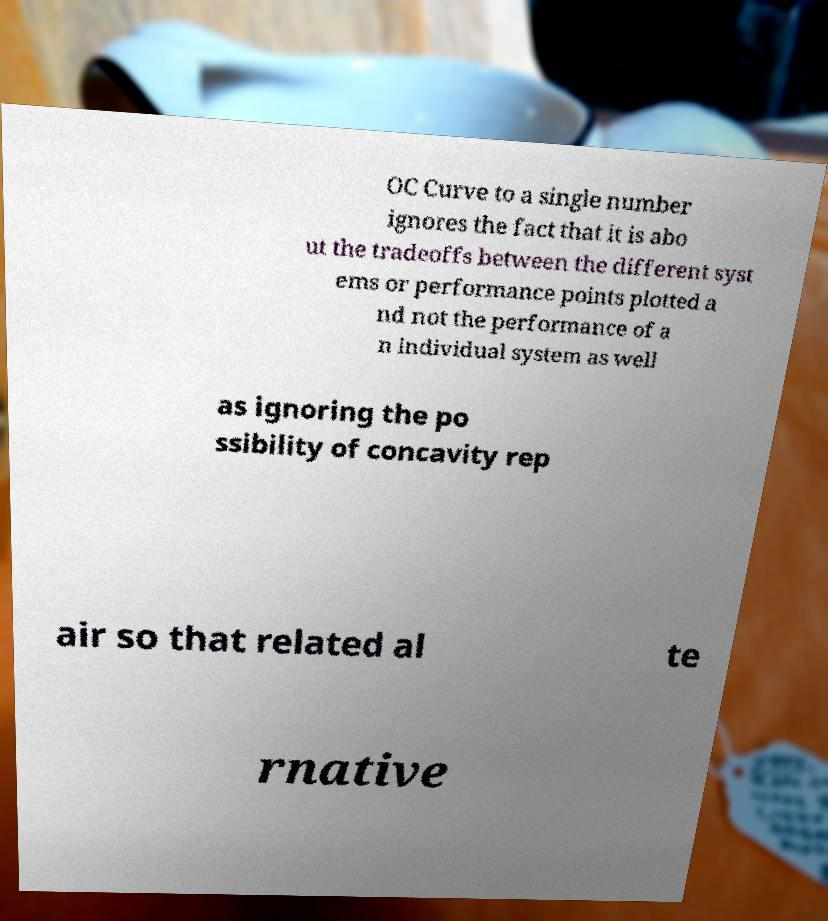For documentation purposes, I need the text within this image transcribed. Could you provide that? OC Curve to a single number ignores the fact that it is abo ut the tradeoffs between the different syst ems or performance points plotted a nd not the performance of a n individual system as well as ignoring the po ssibility of concavity rep air so that related al te rnative 